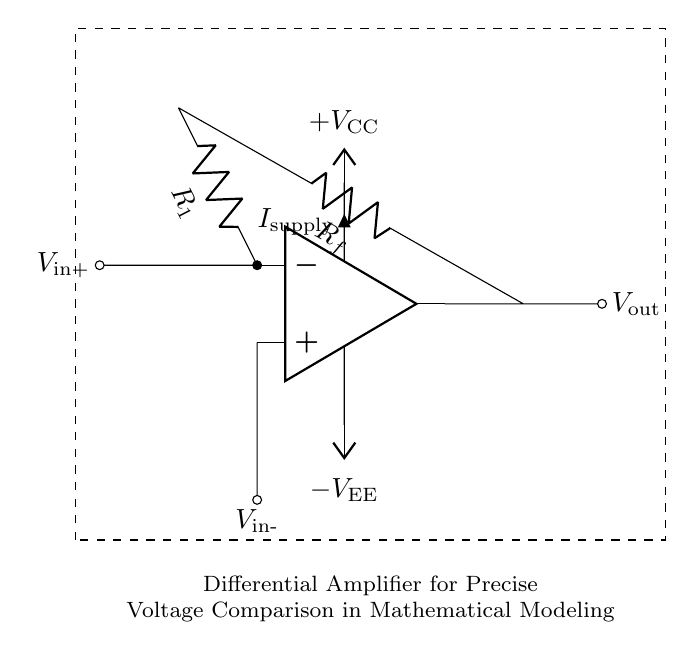What type of amplifier is represented in the circuit? The circuit represents a differential amplifier, which is identified by the op-amp configuration that compares the voltages between two inputs.
Answer: differential amplifier What are the input voltages to the op-amp? The input voltages are indicated as V_in+ and V_in-, which are the non-inverting and inverting inputs, respectively, in the differential amplifier configuration.
Answer: V_in+ and V_in- What is the role of R1 in the circuit? R1 is a resistor connected to the inverting input of the op-amp, which helps determine the gain of the amplifier and affects how the input signals are processed.
Answer: gain determination What is V_out in relation to the input voltages? V_out is the output voltage of the amplifier, which corresponds to the difference between the input voltages V_in+ and V_in- multiplied by the gain defined by the resistors.
Answer: output voltage What do V_CC and V_EE represent in the circuit? V_CC and V_EE represent the supply voltages for the op-amp, where V_CC is the positive supply and V_EE is the negative supply, necessary for proper operation of the amplifier.
Answer: power supplies How does the configuration of this circuit support precise voltage comparison? The differential amplifier effectively amplifies the difference between the two input voltages, rather than amplifying individual voltages, allowing for precise voltage comparison even in the presence of noise or common-mode signals.
Answer: voltage comparison 